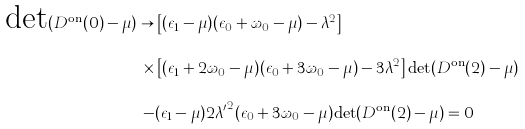Convert formula to latex. <formula><loc_0><loc_0><loc_500><loc_500>\text {det} ( D ^ { \text {on} } ( 0 ) - \mu ) \to & \left [ ( \epsilon _ { 1 } - \mu ) ( \epsilon _ { 0 } + \omega _ { 0 } - \mu ) - \lambda ^ { 2 } \right ] \\ \times & \left [ ( \epsilon _ { 1 } + 2 \omega _ { 0 } - \mu ) ( \epsilon _ { 0 } + 3 \omega _ { 0 } - \mu ) - 3 \lambda ^ { 2 } \right ] \text {det} ( D ^ { \text {on} } ( 2 ) - \mu ) \\ - & ( \epsilon _ { 1 } - \mu ) 2 { \lambda ^ { \prime } } ^ { 2 } ( \epsilon _ { 0 } + 3 \omega _ { 0 } - \mu ) \text {det} ( D ^ { \text {on} } ( 2 ) - \mu ) = 0</formula> 